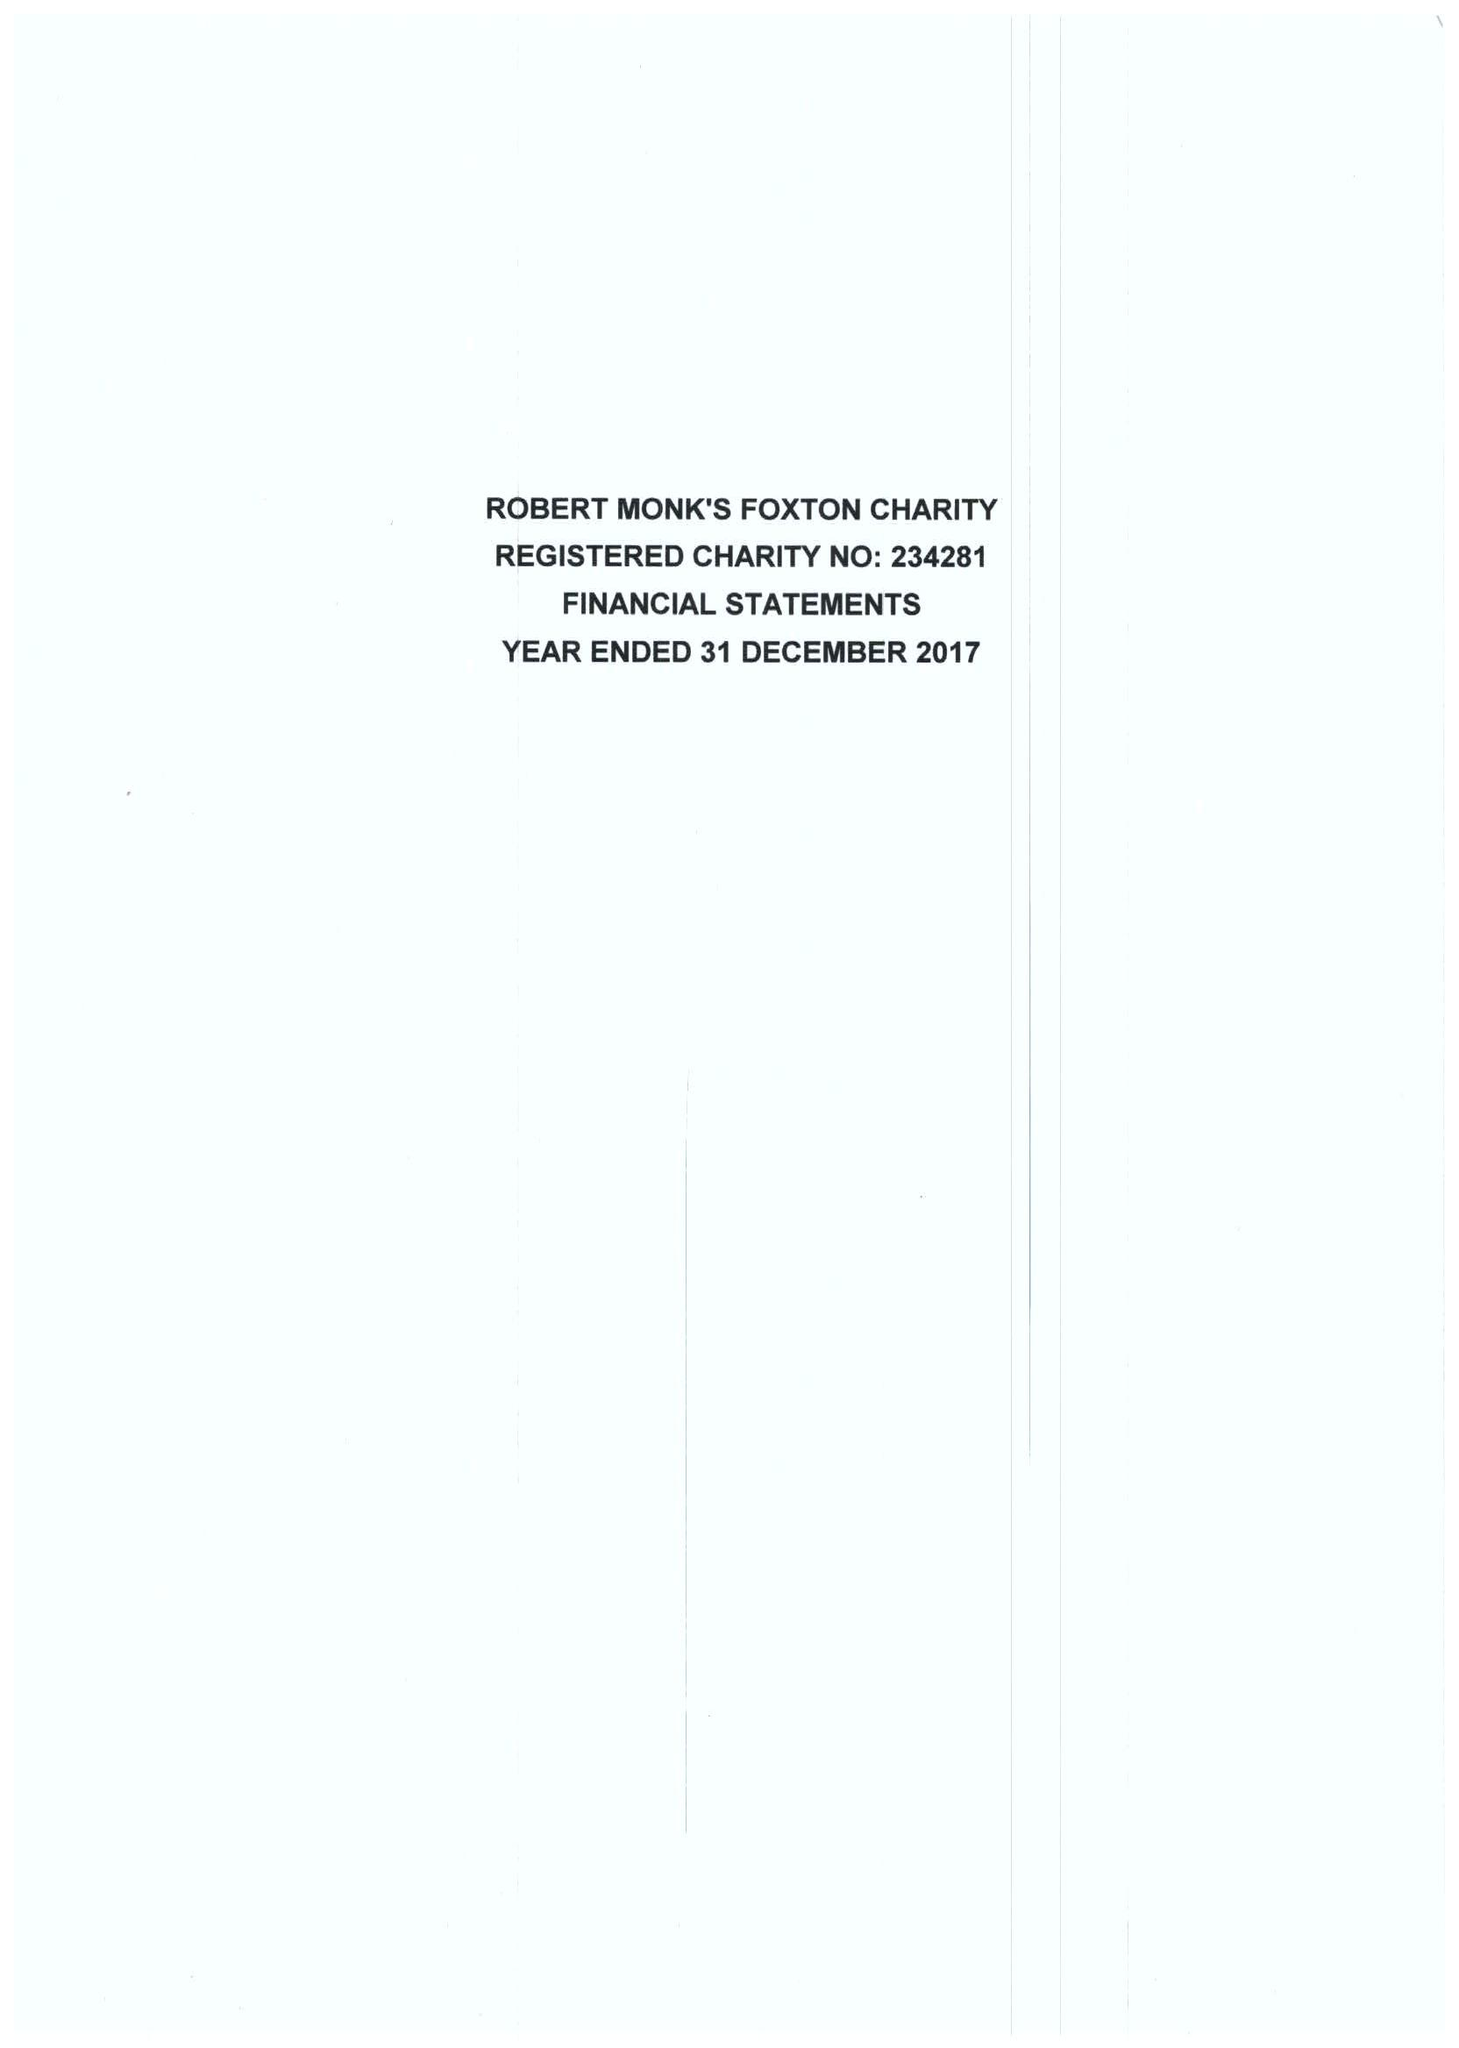What is the value for the charity_name?
Answer the question using a single word or phrase. Robert Monks Foxton Charity 